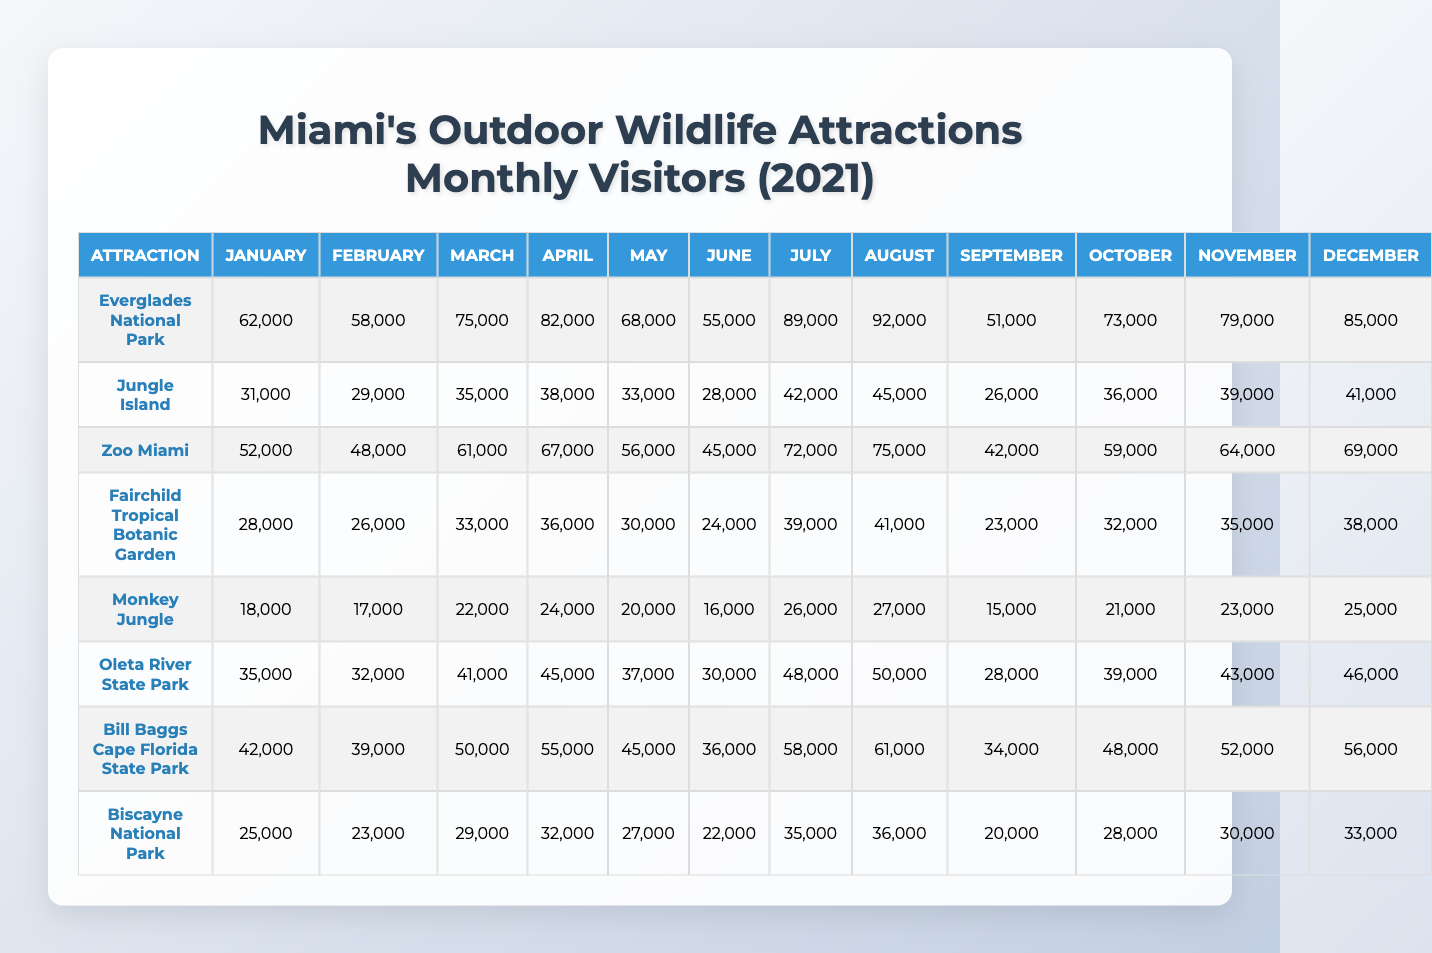What was the visitor count for Zoo Miami in March? Looking at the row for Zoo Miami and the column for March, the visitor count is 61,000.
Answer: 61,000 Which attraction had the highest number of visitors in July? By reviewing the July column for all attractions, we find that Everglades National Park had the highest count with 89,000 visitors.
Answer: Everglades National Park What is the average number of visitors for Biscayne National Park throughout the year? Summing the values for Biscayne National Park across all months gives 272,000. There are 12 months, so the average is 272,000 / 12 = 22,666.67, which rounds to 22,667.
Answer: 22,667 Did Fairchild Tropical Botanic Garden have more than 30,000 visitors in any month? Checking the monthly visitor counts for Fairchild Tropical Botanic Garden, we see that all months exceed 30,000 visitors.
Answer: Yes What month had the lowest total visitor count across all attractions? We need to total the visitors for each month: January (338,000), February (316,000), March (405,000), April (442,000), May (364,000), June (318,000), July (482,000), August (505,000), September (266,000), October (361,000), November (414,000), December (460,000). The lowest is for September with 266,000 visitors.
Answer: September Which attraction had the smallest number of visitors in April? Looking at the April column, we see Monkey Jungle with 24,000 visitors, which is the lowest compared to other attractions.
Answer: Monkey Jungle If we consider the total number of visitors for June, what is that total? Summing the total visitors in June for all attractions gives 300,000.
Answer: 300,000 Which attraction had a consistent increase in visitors from January to August? Reviewing the visitor trends, Zoo Miami shows an increase from 52,000 in January to 75,000 in August, indicating an upward trend.
Answer: Zoo Miami 